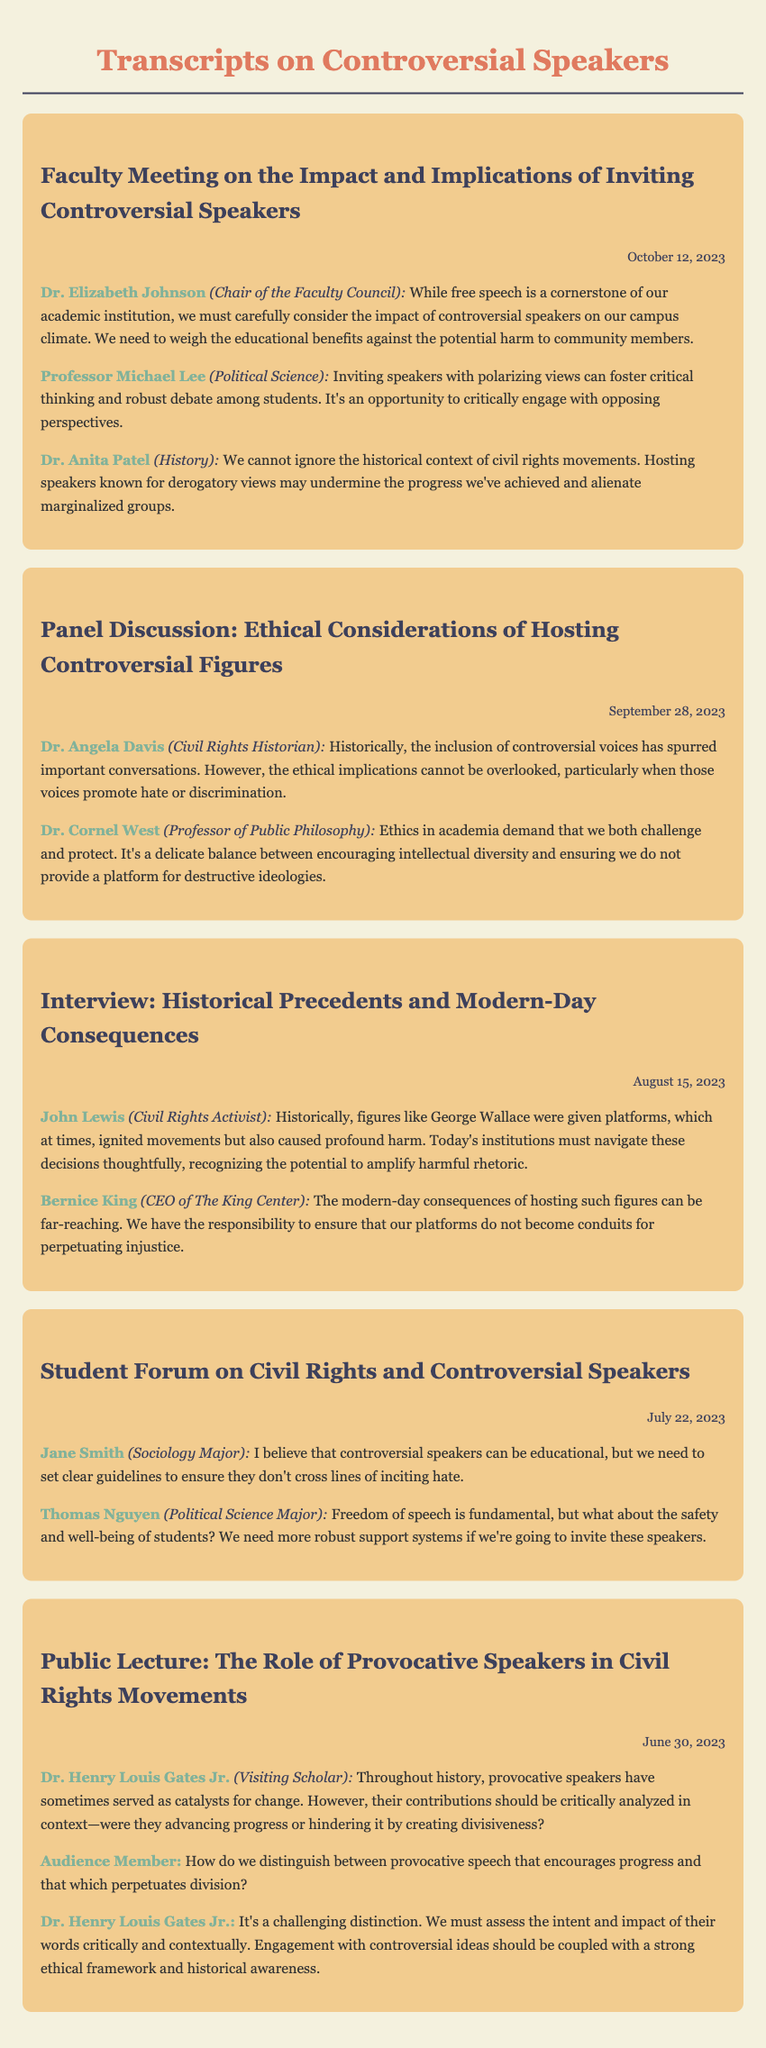What is the date of the faculty meeting? The date is specified in the document as October 12, 2023.
Answer: October 12, 2023 Who is the chair of the faculty council? The document mentions Dr. Elizabeth Johnson as the Chair of the Faculty Council.
Answer: Dr. Elizabeth Johnson What does Dr. Anita Patel highlight about hosting derogatory speakers? Dr. Patel mentions that it may undermine progress and alienate marginalized groups.
Answer: Undermine progress and alienate marginalized groups Which panelist expresses concern about providing a platform for hate? Dr. Angela Davis discusses the ethical implications regarding this issue.
Answer: Dr. Angela Davis What major theme does John Lewis speak about in the interview? He reflects on the historical impact and harm caused by giving platforms to figures like George Wallace.
Answer: Historical impact and harm How does Dr. Henry Louis Gates Jr. suggest we analyze provocative speech? He suggests that it should be critically analyzed in context regarding whether it advances or hinders progress.
Answer: Critically analyzed in context What is a suggested guideline for inviting controversial speakers according to Jane Smith? Jane Smith emphasizes the need for clear guidelines to avoid inciting hate.
Answer: Clear guidelines to avoid inciting hate What fundamental principle does Thomas Nguyen mention as important? He highlights that freedom of speech is fundamental when discussing controversial speakers.
Answer: Freedom of speech What historical role do provocative speakers have in civil rights movements according to Dr. Gates? He mentions that they can serve as catalysts for change.
Answer: Catalysts for change 